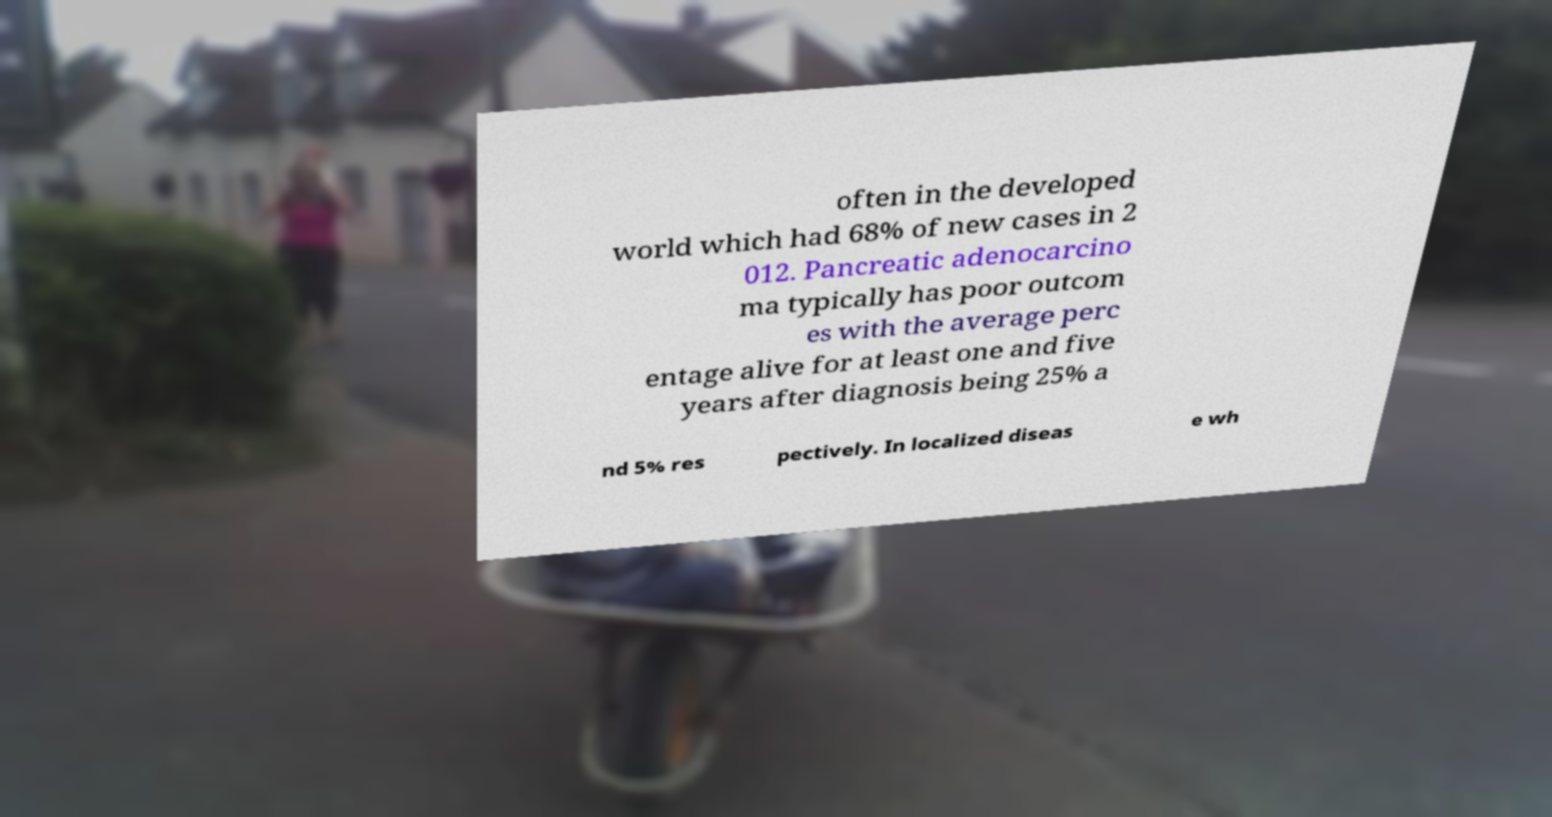For documentation purposes, I need the text within this image transcribed. Could you provide that? often in the developed world which had 68% of new cases in 2 012. Pancreatic adenocarcino ma typically has poor outcom es with the average perc entage alive for at least one and five years after diagnosis being 25% a nd 5% res pectively. In localized diseas e wh 